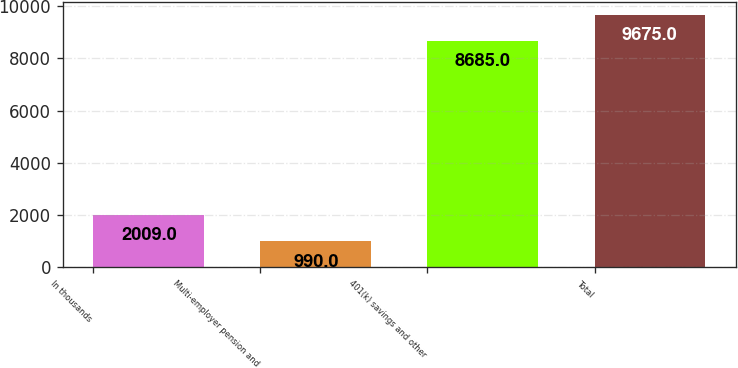Convert chart. <chart><loc_0><loc_0><loc_500><loc_500><bar_chart><fcel>In thousands<fcel>Multi-employer pension and<fcel>401(k) savings and other<fcel>Total<nl><fcel>2009<fcel>990<fcel>8685<fcel>9675<nl></chart> 